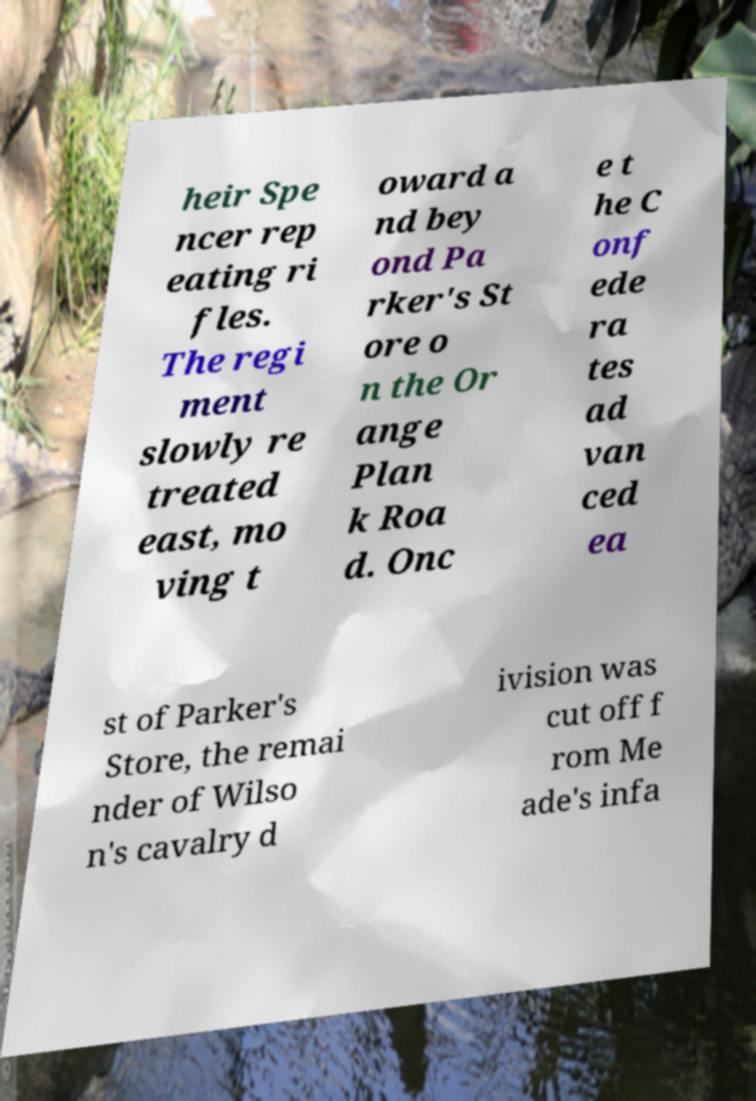Could you assist in decoding the text presented in this image and type it out clearly? heir Spe ncer rep eating ri fles. The regi ment slowly re treated east, mo ving t oward a nd bey ond Pa rker's St ore o n the Or ange Plan k Roa d. Onc e t he C onf ede ra tes ad van ced ea st of Parker's Store, the remai nder of Wilso n's cavalry d ivision was cut off f rom Me ade's infa 